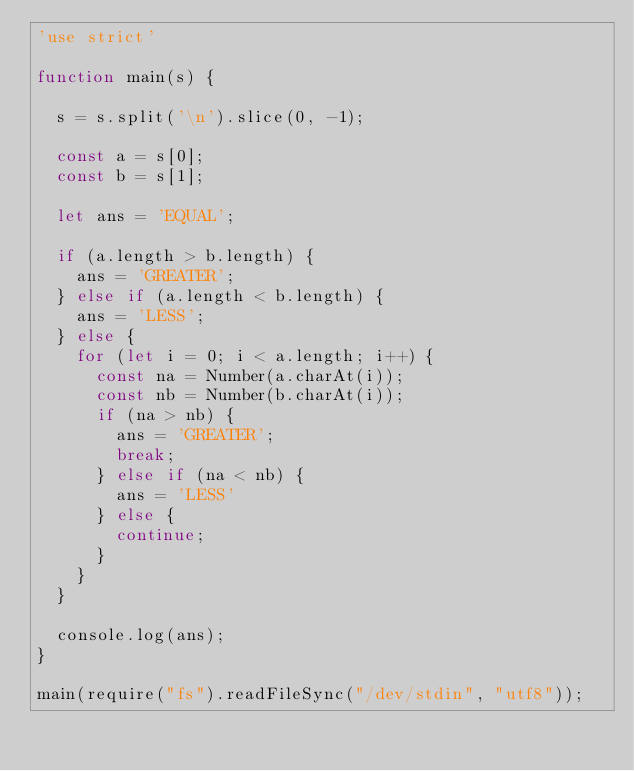Convert code to text. <code><loc_0><loc_0><loc_500><loc_500><_JavaScript_>'use strict'

function main(s) {

  s = s.split('\n').slice(0, -1);

  const a = s[0];
  const b = s[1];

  let ans = 'EQUAL';

  if (a.length > b.length) {
    ans = 'GREATER';
  } else if (a.length < b.length) {
    ans = 'LESS';
  } else {
    for (let i = 0; i < a.length; i++) {
      const na = Number(a.charAt(i));
      const nb = Number(b.charAt(i));
      if (na > nb) {
        ans = 'GREATER';
        break;
      } else if (na < nb) {
        ans = 'LESS'
      } else {
        continue;
      }
    }
  }

  console.log(ans);
}

main(require("fs").readFileSync("/dev/stdin", "utf8"));
</code> 